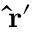Convert formula to latex. <formula><loc_0><loc_0><loc_500><loc_500>{ \hat { r } } ^ { \prime }</formula> 